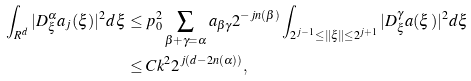Convert formula to latex. <formula><loc_0><loc_0><loc_500><loc_500>\int _ { R ^ { d } } | D ^ { \alpha } _ { \xi } { a } _ { j } ( \xi ) | ^ { 2 } d \xi & \leq p ^ { 2 } _ { 0 } \sum _ { \beta + \gamma = \alpha } a _ { \beta \gamma } 2 ^ { - j n ( \beta ) } \int _ { 2 ^ { j - 1 } \leq \| \xi \| \leq 2 ^ { j + 1 } } | D ^ { \gamma } _ { \xi } { a } ( \xi ) | ^ { 2 } d \xi \\ & \leq C k ^ { 2 } 2 ^ { j ( d - 2 n ( \alpha ) ) } ,</formula> 